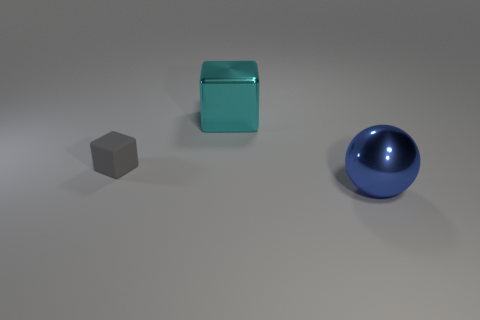Is there anything else that is the same shape as the large blue metallic object?
Your response must be concise. No. Is there any other thing that has the same size as the matte thing?
Keep it short and to the point. No. There is a thing that is right of the tiny object and on the left side of the ball; what material is it made of?
Keep it short and to the point. Metal. Does the big metallic object that is in front of the matte block have the same shape as the big object behind the ball?
Give a very brief answer. No. Is there a tiny thing?
Provide a short and direct response. Yes. The other object that is the same shape as the rubber object is what color?
Ensure brevity in your answer.  Cyan. There is another metal thing that is the same size as the cyan thing; what is its color?
Provide a succinct answer. Blue. Is the gray block made of the same material as the big ball?
Offer a very short reply. No. Is the large ball the same color as the metallic block?
Offer a very short reply. No. What is the material of the cyan thing that is behind the blue thing?
Offer a very short reply. Metal. 